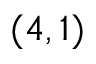Convert formula to latex. <formula><loc_0><loc_0><loc_500><loc_500>( 4 , 1 )</formula> 